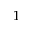Convert formula to latex. <formula><loc_0><loc_0><loc_500><loc_500>1</formula> 